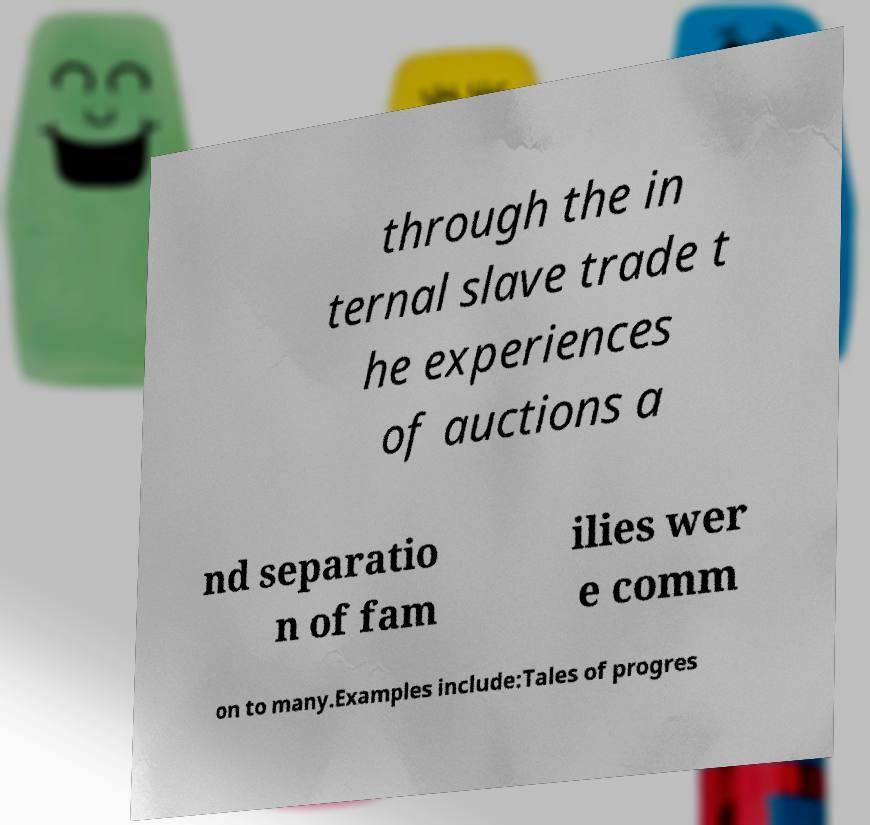There's text embedded in this image that I need extracted. Can you transcribe it verbatim? through the in ternal slave trade t he experiences of auctions a nd separatio n of fam ilies wer e comm on to many.Examples include:Tales of progres 